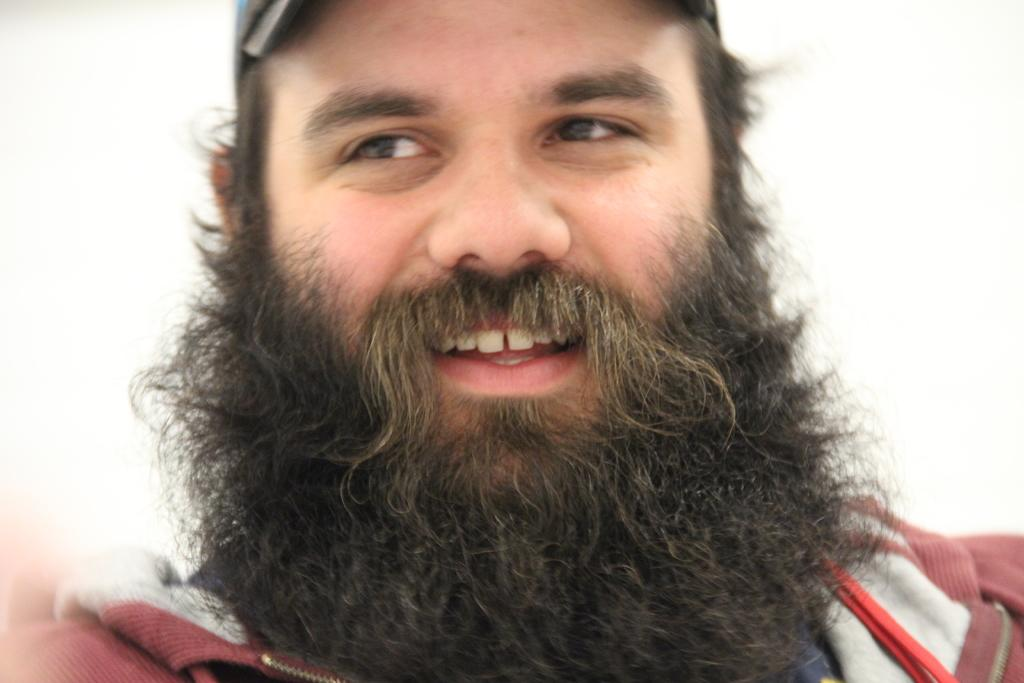What is the main subject of the image? There is a man in the image. What color is the background of the image? The background of the image is white in color. What type of stick is the man holding in the image? There is no stick present in the image. How many cubs are visible in the image? There are no cubs present in the image. 